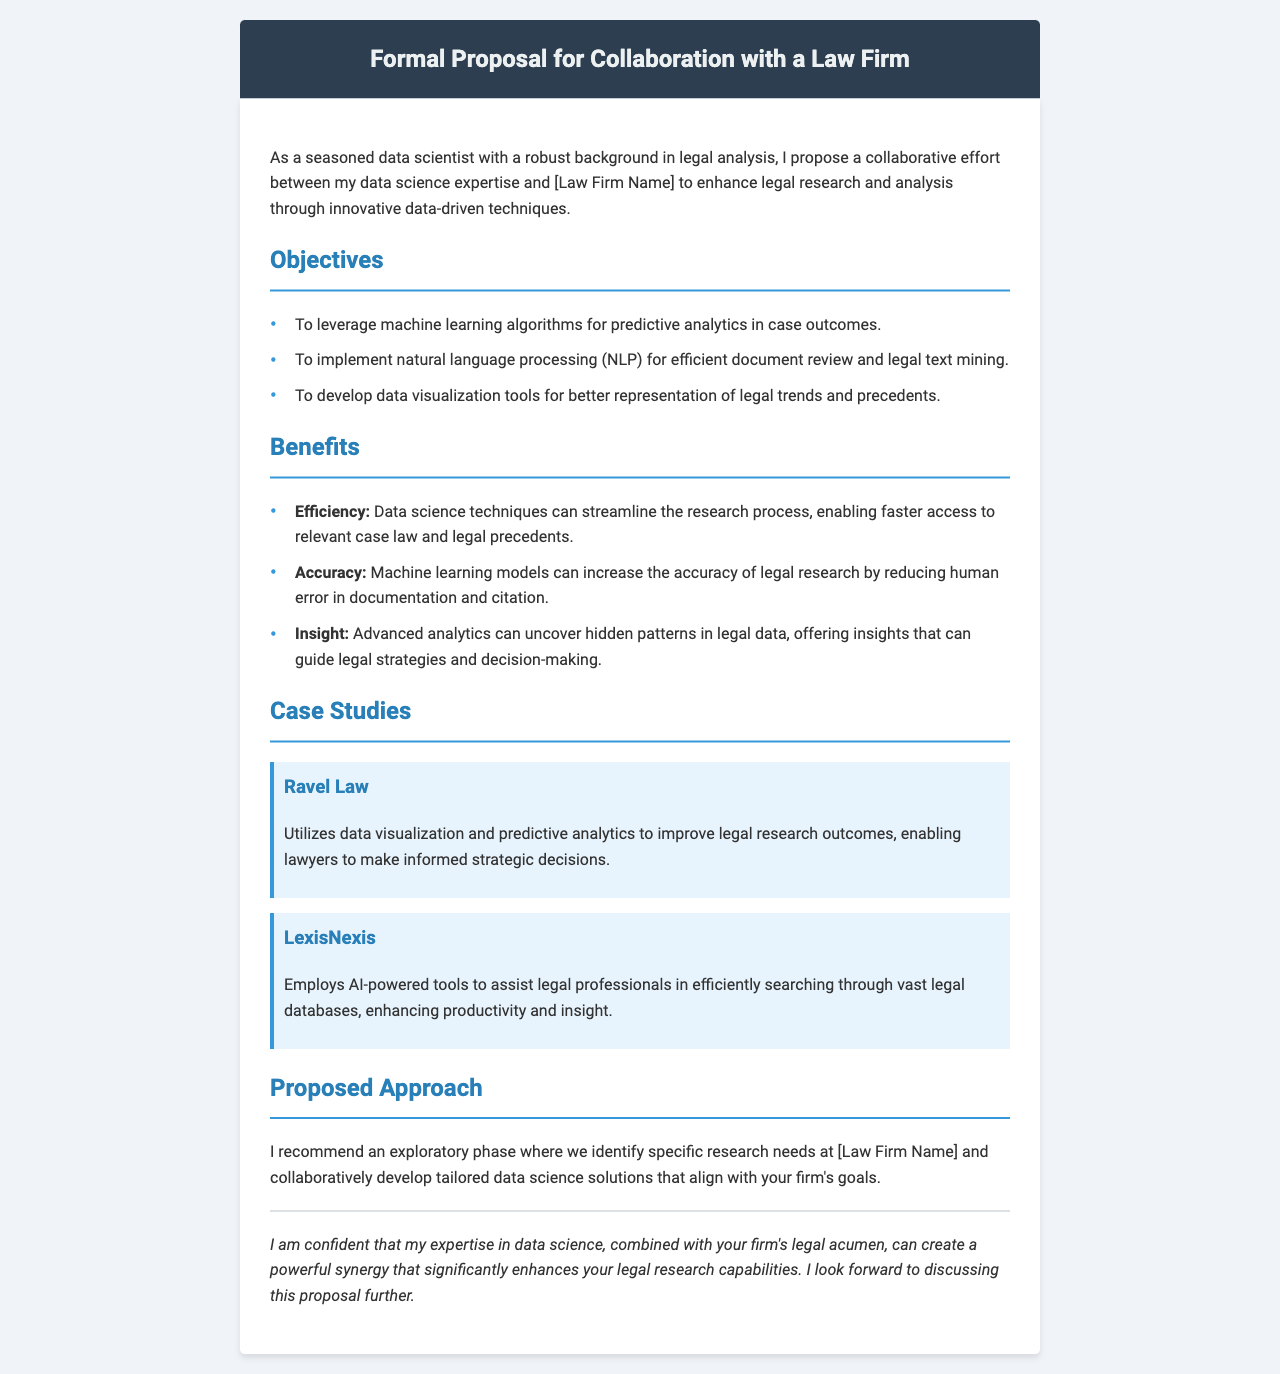What are the main objectives of the proposal? The objectives are outlined in a bulleted list, including leveraging machine learning algorithms, implementing natural language processing, and developing data visualization tools.
Answer: To leverage machine learning algorithms for predictive analytics in case outcomes, to implement natural language processing for efficient document review and legal text mining, to develop data visualization tools for better representation of legal trends and precedents What does the case study of Ravel Law highlight? The case study describes how Ravel Law uses particular data science techniques to improve legal research outcomes.
Answer: Utilizes data visualization and predictive analytics to improve legal research outcomes, enabling lawyers to make informed strategic decisions What is one benefit of using data science in legal research? The document lists benefits of data science techniques, emphasizing how they contribute to the legal research process.
Answer: Efficiency What is the proposed first step in the collaboration? The proposal outlines an approach, specifying that the first phase involves identifying specific research needs.
Answer: An exploratory phase where we identify specific research needs Who is the author of the proposal? The author is identified in the introduction of the document, establishing their credentials and background.
Answer: A seasoned data scientist 